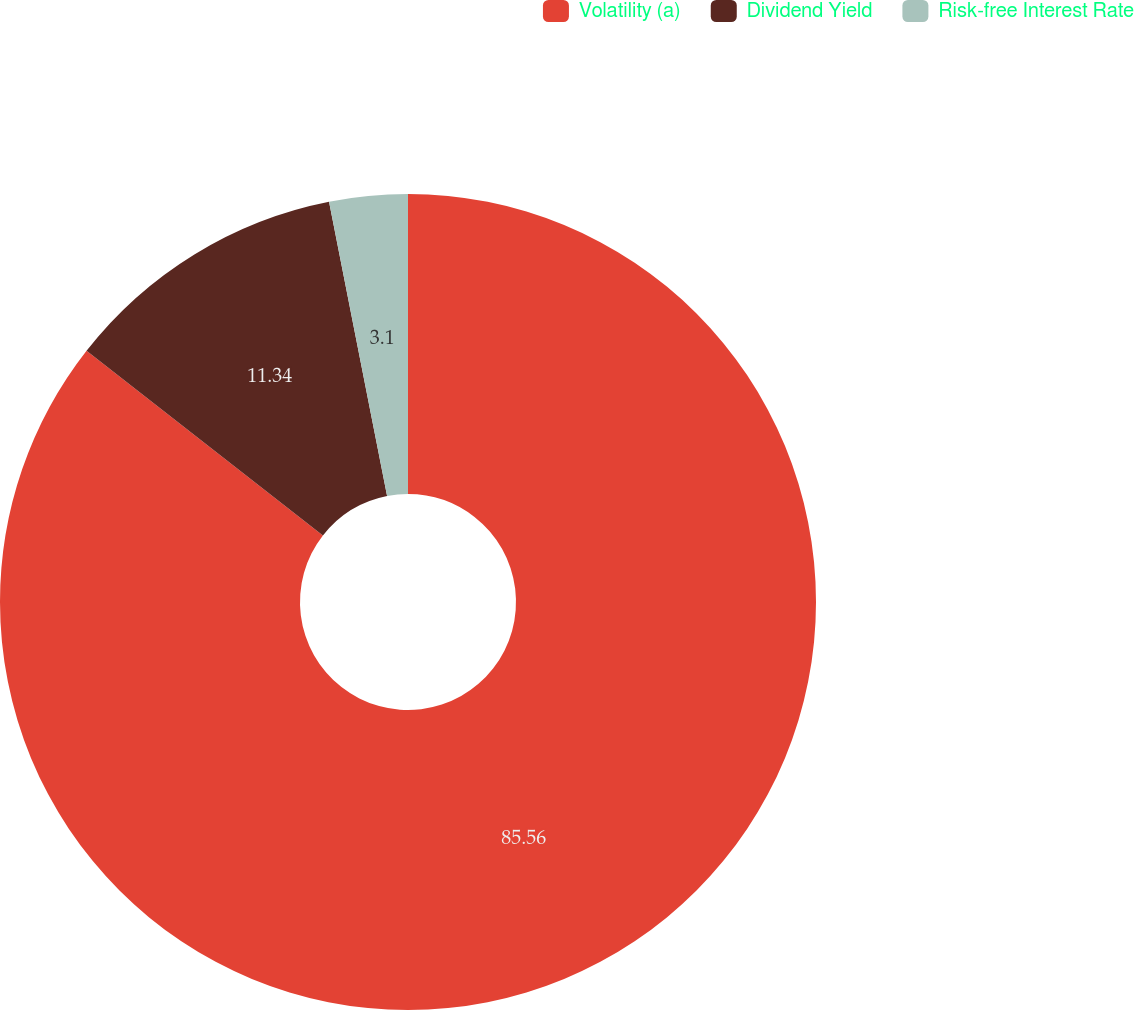Convert chart to OTSL. <chart><loc_0><loc_0><loc_500><loc_500><pie_chart><fcel>Volatility (a)<fcel>Dividend Yield<fcel>Risk-free Interest Rate<nl><fcel>85.56%<fcel>11.34%<fcel>3.1%<nl></chart> 